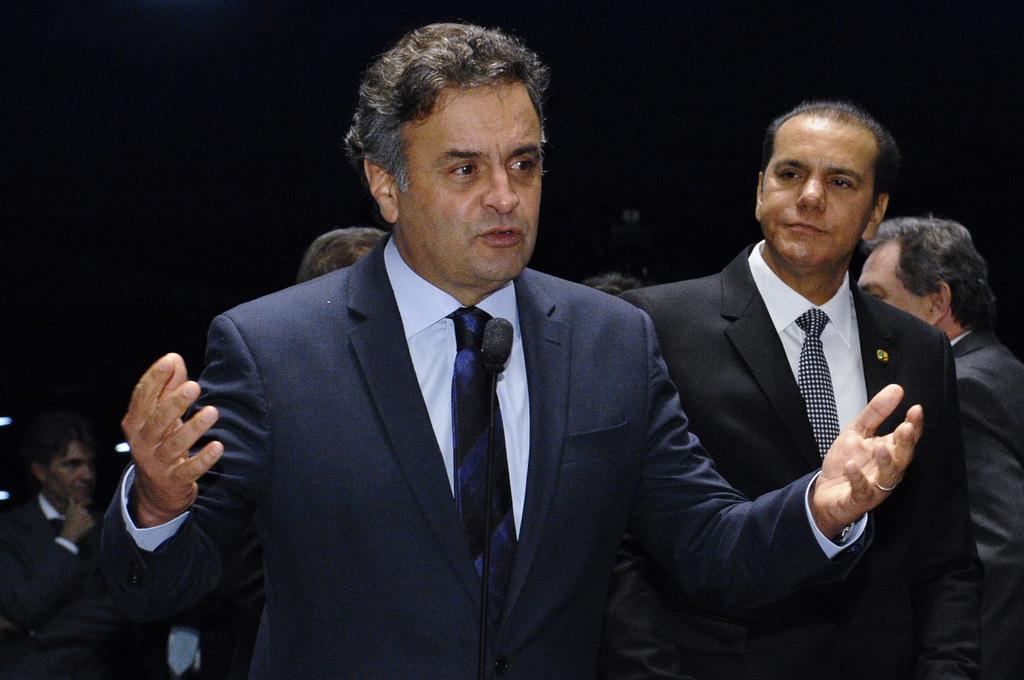How would you summarize this image in a sentence or two? In the image there is a man with navy blue jacket, white shirt and tie is standing and in front of him there is a mic. Beside him there is a man with black jacket, white shirt and tie is standing. Behind them there are few people. And there is a black background. 